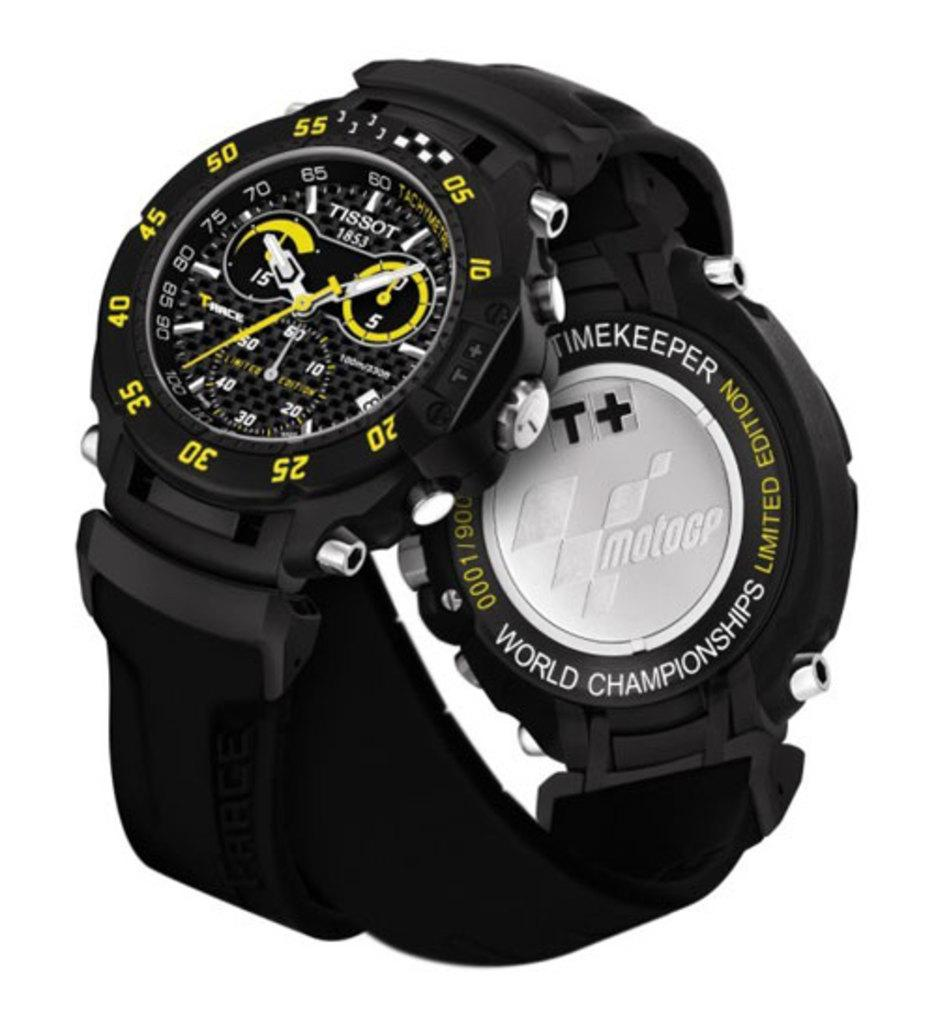Provide a one-sentence caption for the provided image. A black, white and yellow Tissot 1852 World Championships Limited Edition watch. 